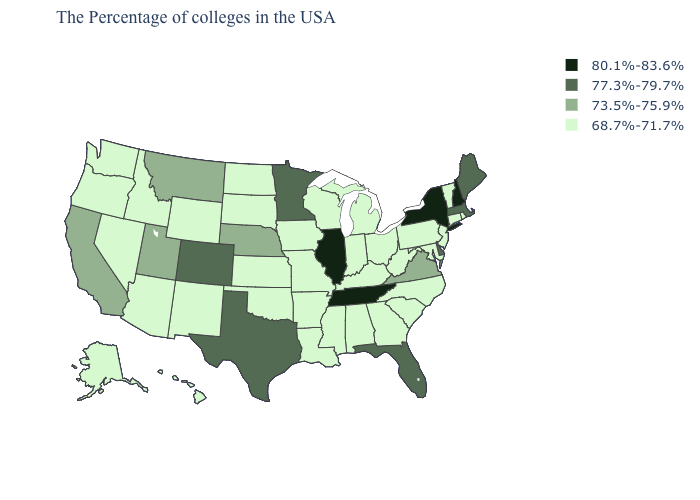What is the value of Ohio?
Quick response, please. 68.7%-71.7%. Among the states that border West Virginia , which have the lowest value?
Give a very brief answer. Maryland, Pennsylvania, Ohio, Kentucky. What is the value of Indiana?
Short answer required. 68.7%-71.7%. Name the states that have a value in the range 73.5%-75.9%?
Quick response, please. Virginia, Nebraska, Utah, Montana, California. What is the value of Maryland?
Keep it brief. 68.7%-71.7%. Does Kansas have the lowest value in the MidWest?
Quick response, please. Yes. Name the states that have a value in the range 80.1%-83.6%?
Give a very brief answer. New Hampshire, New York, Tennessee, Illinois. Does New York have the same value as New Hampshire?
Quick response, please. Yes. Name the states that have a value in the range 73.5%-75.9%?
Answer briefly. Virginia, Nebraska, Utah, Montana, California. What is the highest value in the MidWest ?
Keep it brief. 80.1%-83.6%. Which states have the lowest value in the MidWest?
Keep it brief. Ohio, Michigan, Indiana, Wisconsin, Missouri, Iowa, Kansas, South Dakota, North Dakota. Which states have the highest value in the USA?
Concise answer only. New Hampshire, New York, Tennessee, Illinois. Does Delaware have the same value as Tennessee?
Answer briefly. No. What is the value of Indiana?
Keep it brief. 68.7%-71.7%. Does Florida have the highest value in the South?
Write a very short answer. No. 